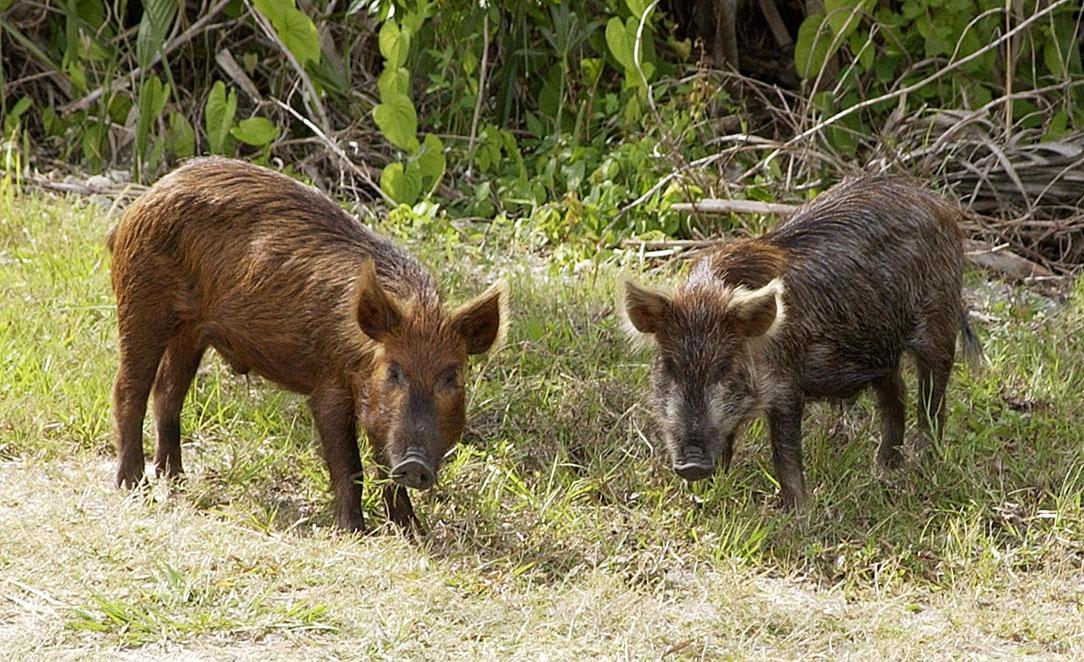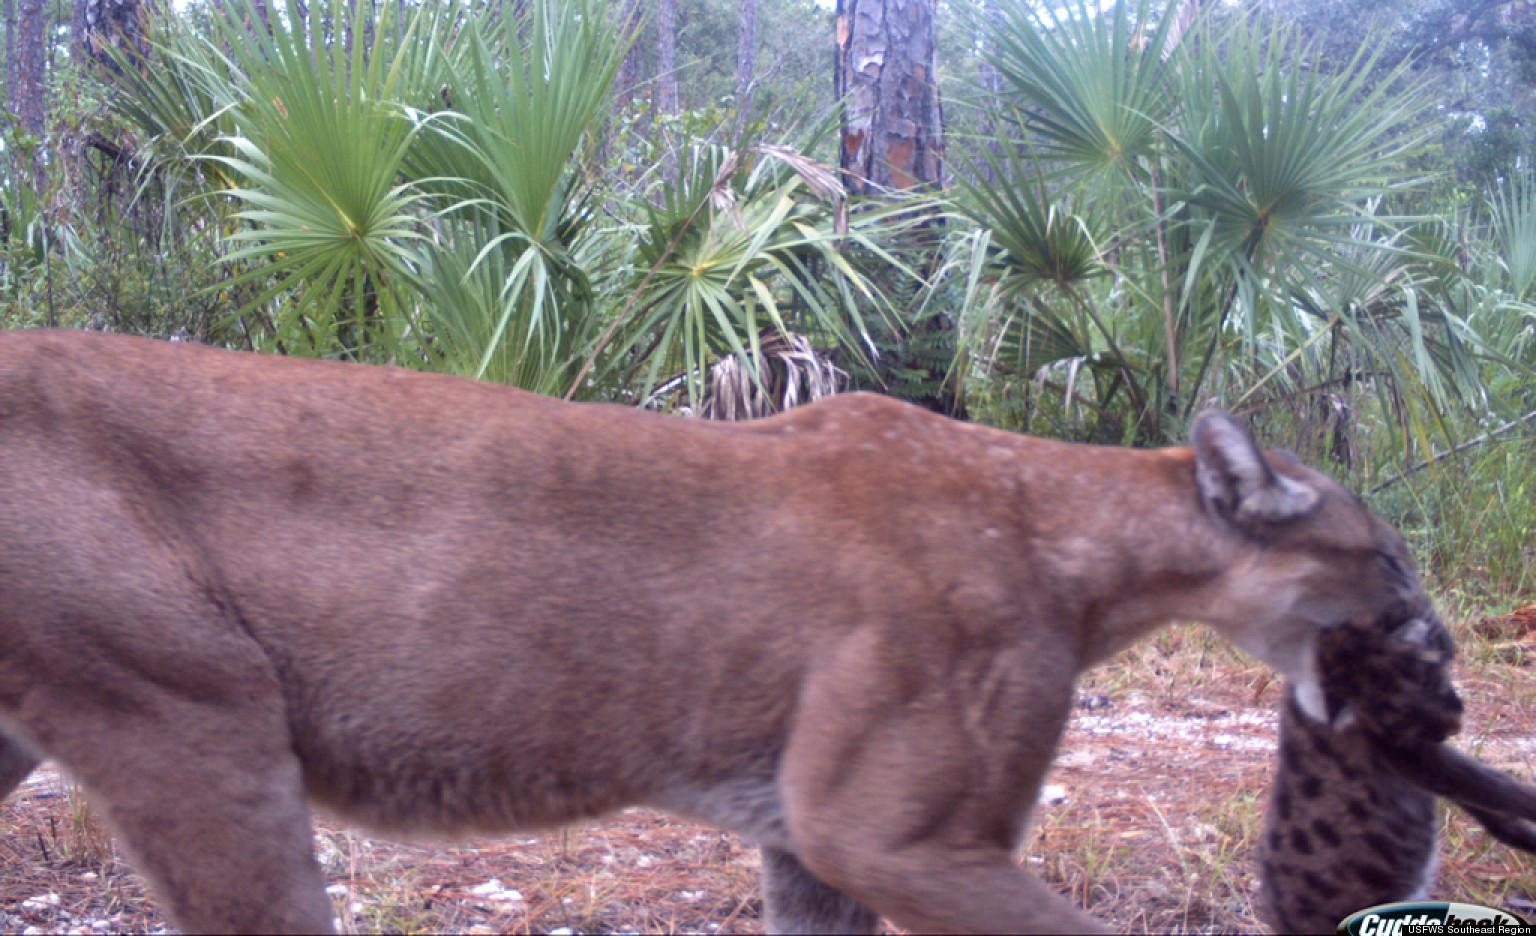The first image is the image on the left, the second image is the image on the right. For the images displayed, is the sentence "At least one of the animals pictured is dead." factually correct? Answer yes or no. Yes. 